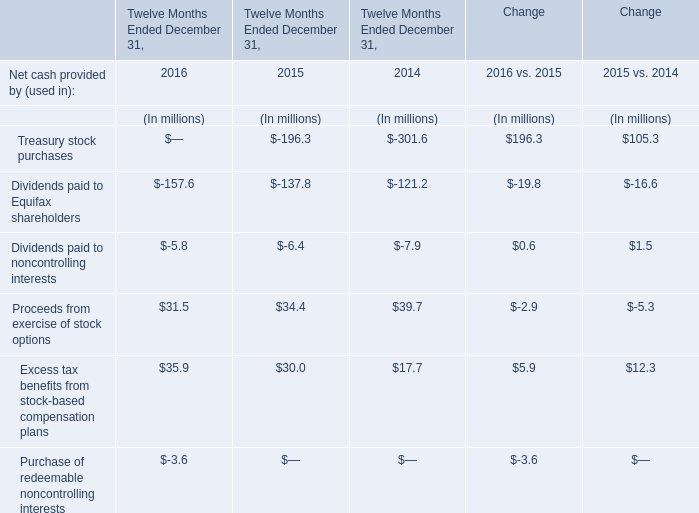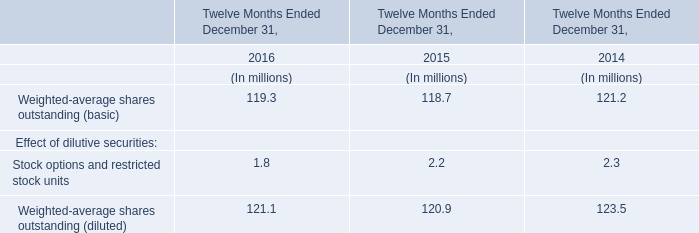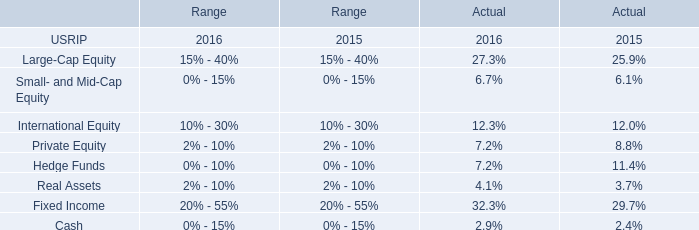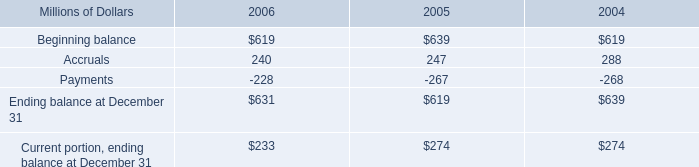Does the value of Proceeds from exercise of stock options in 2016 greater than that in 2015? 
Answer: no. 